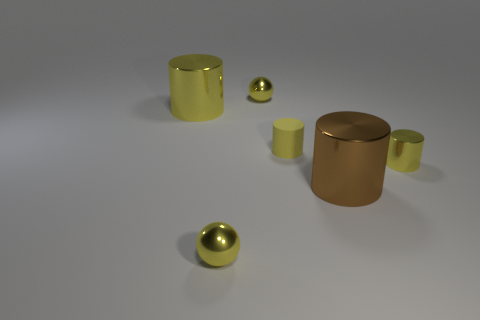Is the shape of the yellow matte thing the same as the large yellow object?
Provide a short and direct response. Yes. There is another rubber thing that is the same shape as the big yellow object; what is its size?
Your answer should be compact. Small. There is a tiny metallic thing that is the same shape as the big yellow shiny thing; what is its color?
Provide a succinct answer. Yellow. What number of small shiny cylinders are the same color as the small matte object?
Your response must be concise. 1. Do the small yellow thing that is right of the large brown cylinder and the small rubber object have the same shape?
Give a very brief answer. Yes. There is another large cylinder that is the same material as the large yellow cylinder; what is its color?
Your answer should be very brief. Brown. What number of small blue spheres have the same material as the big yellow cylinder?
Your answer should be compact. 0. There is a matte cylinder; is its color the same as the metal thing that is behind the large yellow shiny thing?
Ensure brevity in your answer.  Yes. There is a ball that is behind the tiny yellow metal object that is in front of the tiny yellow shiny cylinder; what color is it?
Keep it short and to the point. Yellow. There is a shiny object that is the same size as the brown cylinder; what is its color?
Offer a terse response. Yellow. 